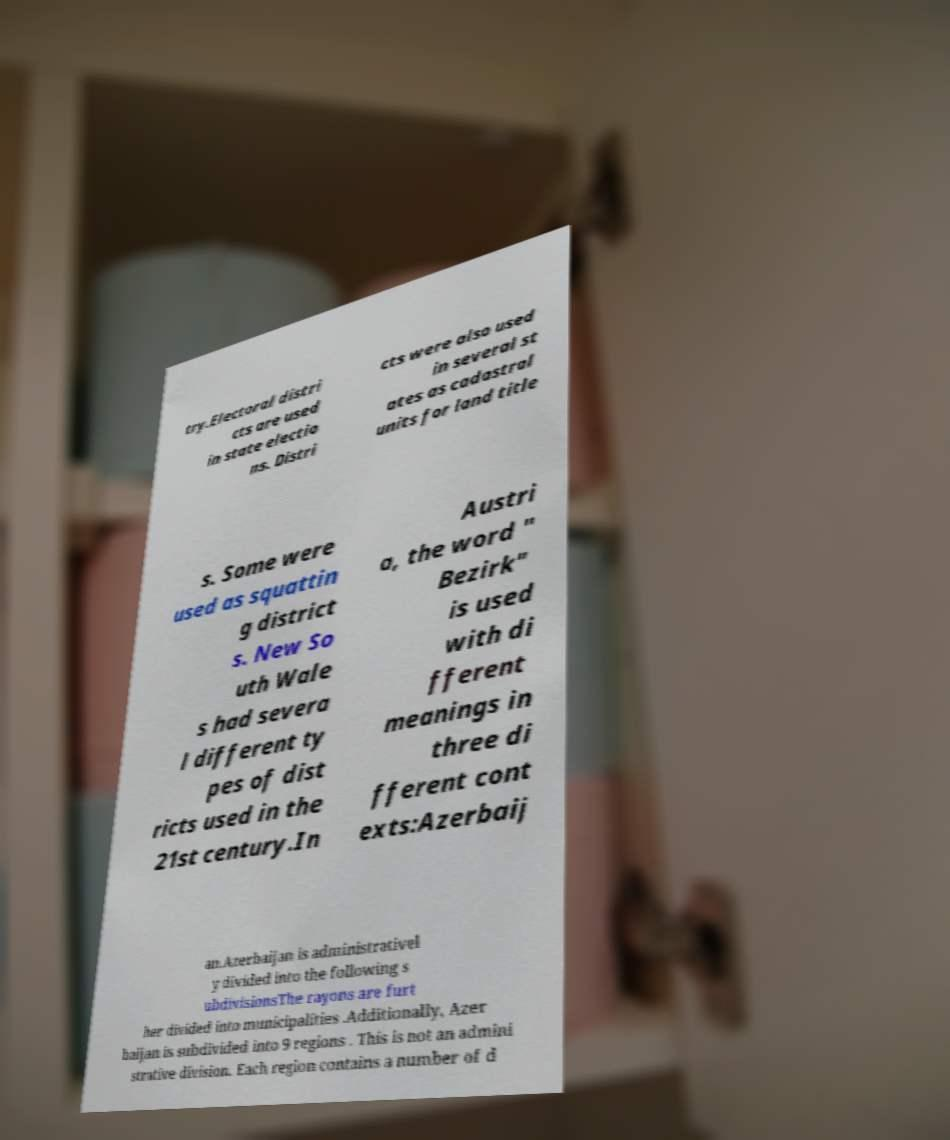What messages or text are displayed in this image? I need them in a readable, typed format. try.Electoral distri cts are used in state electio ns. Distri cts were also used in several st ates as cadastral units for land title s. Some were used as squattin g district s. New So uth Wale s had severa l different ty pes of dist ricts used in the 21st century.In Austri a, the word " Bezirk" is used with di fferent meanings in three di fferent cont exts:Azerbaij an.Azerbaijan is administrativel y divided into the following s ubdivisionsThe rayons are furt her divided into municipalities .Additionally, Azer baijan is subdivided into 9 regions . This is not an admini strative division. Each region contains a number of d 